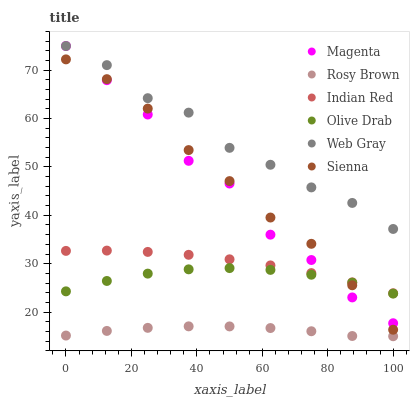Does Rosy Brown have the minimum area under the curve?
Answer yes or no. Yes. Does Web Gray have the maximum area under the curve?
Answer yes or no. Yes. Does Sienna have the minimum area under the curve?
Answer yes or no. No. Does Sienna have the maximum area under the curve?
Answer yes or no. No. Is Indian Red the smoothest?
Answer yes or no. Yes. Is Magenta the roughest?
Answer yes or no. Yes. Is Rosy Brown the smoothest?
Answer yes or no. No. Is Rosy Brown the roughest?
Answer yes or no. No. Does Rosy Brown have the lowest value?
Answer yes or no. Yes. Does Sienna have the lowest value?
Answer yes or no. No. Does Magenta have the highest value?
Answer yes or no. Yes. Does Sienna have the highest value?
Answer yes or no. No. Is Olive Drab less than Web Gray?
Answer yes or no. Yes. Is Web Gray greater than Sienna?
Answer yes or no. Yes. Does Web Gray intersect Magenta?
Answer yes or no. Yes. Is Web Gray less than Magenta?
Answer yes or no. No. Is Web Gray greater than Magenta?
Answer yes or no. No. Does Olive Drab intersect Web Gray?
Answer yes or no. No. 